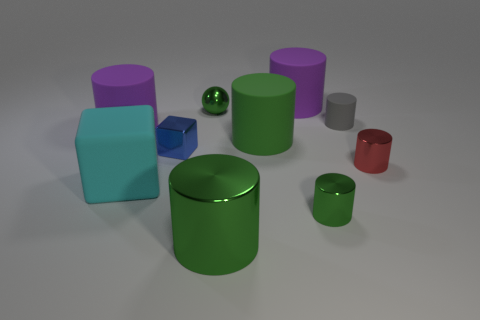How many purple cylinders must be subtracted to get 1 purple cylinders? 1 Subtract all cyan blocks. How many green cylinders are left? 3 Subtract all red cylinders. How many cylinders are left? 6 Subtract all red cylinders. How many cylinders are left? 6 Subtract all green cylinders. Subtract all green balls. How many cylinders are left? 4 Subtract all cylinders. How many objects are left? 3 Add 6 big green cylinders. How many big green cylinders are left? 8 Add 1 metallic balls. How many metallic balls exist? 2 Subtract 0 gray cubes. How many objects are left? 10 Subtract all big brown blocks. Subtract all small metal cylinders. How many objects are left? 8 